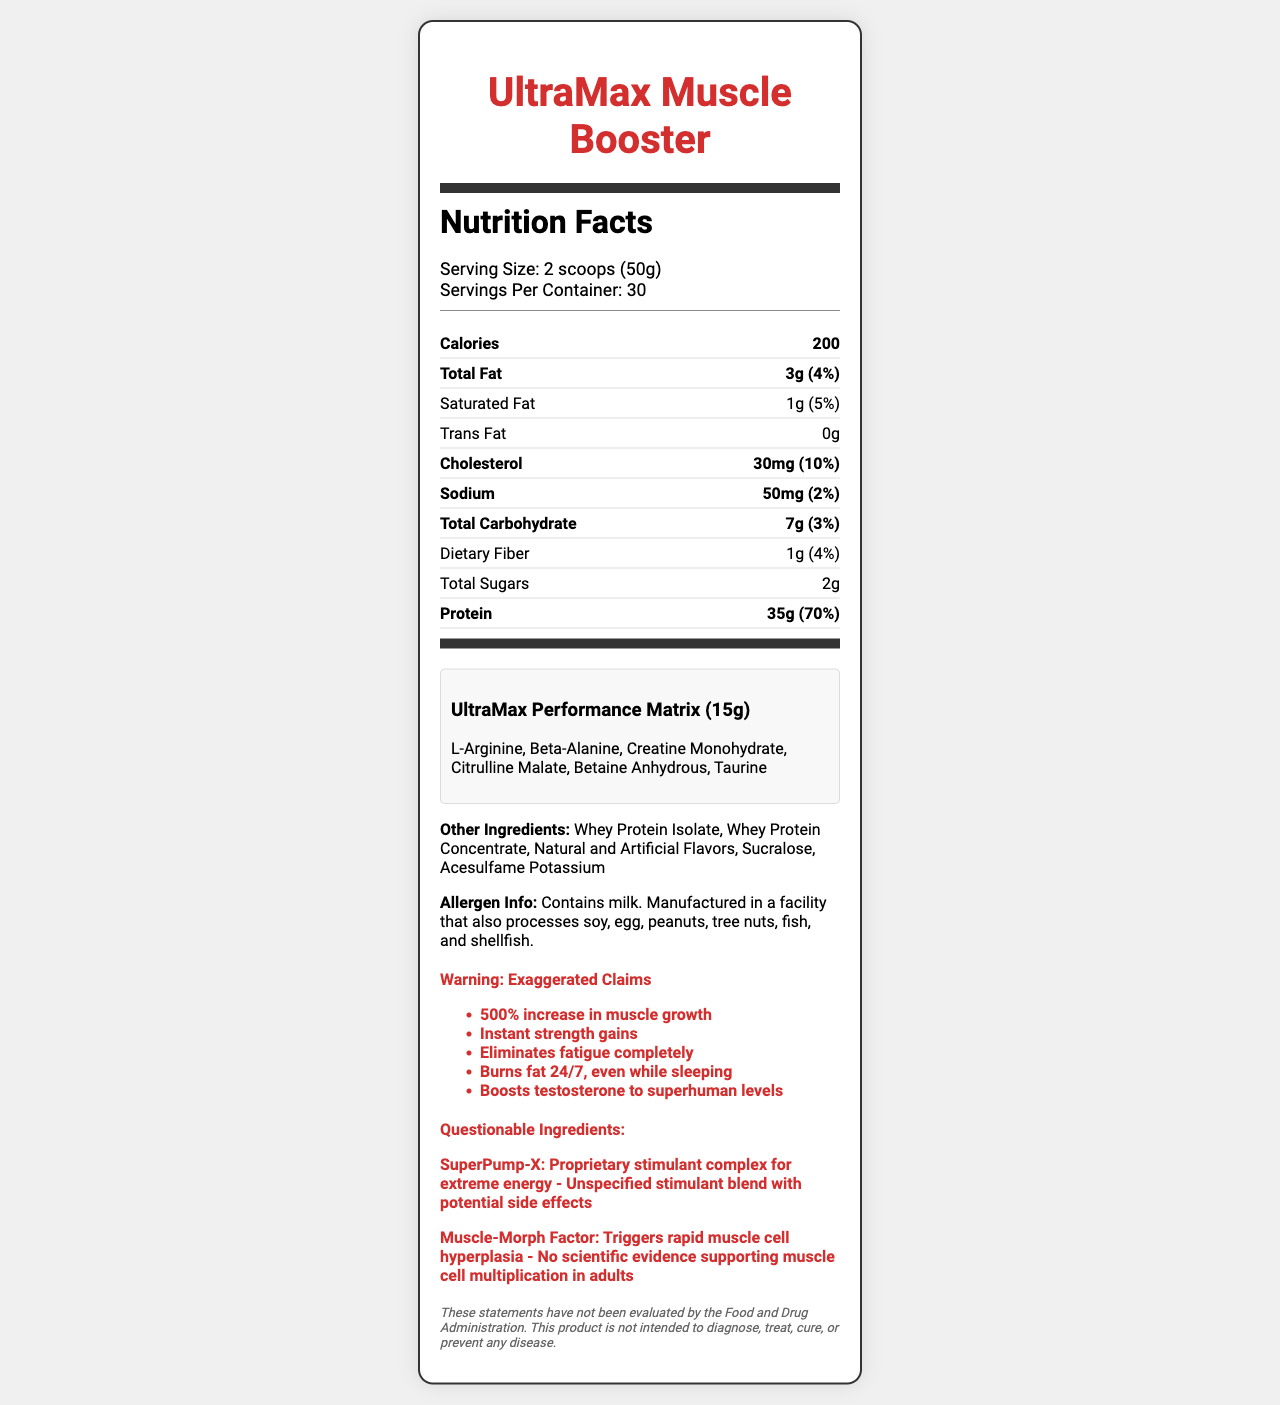what is the serving size of UltraMax Muscle Booster? The serving size is stated as "2 scoops (50g)" in the serving information section of the document.
Answer: 2 scoops (50g) how many calories are there per serving? The calories per serving is listed as 200.
Answer: 200 what is the total protein content per serving? The total protein content is listed as "35g" in the nutrient table.
Answer: 35g identify one questionable ingredient and its claimed benefit. This information is provided in the "Questionable Ingredients" section, where the ingredient SuperPump-X is claimed to be a proprietary stimulant complex for extreme energy.
Answer: SuperPump-X: Proprietary stimulant complex for extreme energy how many servings are there per container? The number of servings per container is given as 30 in the serving information section.
Answer: 30 what percentage of daily value does the cholesterol per serving contribute? A. 6% B. 10% C. 15% D. 20% The daily value percentage for cholesterol is listed as 10%.
Answer: B which of these is not listed as an ingredient for UltraMax Muscle Booster? I. Whey Protein Isolate II. Sucralose III. Aspartame IV. L-Arginine Aspartame is not listed under either the proprietary blend or other ingredients.
Answer: III is there any dietary fiber in this product? The nutrient table lists 1g of dietary fiber with a daily value of 4%.
Answer: Yes does this product boost testosterone to superhuman levels according to its claims? One of the exaggerated claims listed is "Boosts testosterone to superhuman levels."
Answer: Yes summarize the main idea of the document. The document primarily provides detailed nutritional information and ingredients of the UltraMax Muscle Booster, highlights exaggerated performance claims, and mentions questionable ingredients along with a disclaimer.
Answer: The document is a nutrition facts label for the sports nutrition supplement UltraMax Muscle Booster. It provides nutritional information, ingredient lists (including a proprietary blend and other ingredients), exaggerated performance claims, and highlights questionable ingredients. A disclaimer is included noting that the claims have not been evaluated by the FDA. how much vitamin D is present in each serving? According to the nutrient table, vitamin D content is 0 mcg with a daily value of 0%.
Answer: 0 mcg identify two flavors used in this product. The Other Ingredients section lists "Natural and Artificial Flavors".
Answer: Natural and Artificial Flavors is there any data supporting the "Muscle-Morph Factor" claim? The document notes that there is no scientific evidence supporting the muscle cell multiplication claim made by the "Muscle-Morph Factor."
Answer: No is the daily value percentage for total carbohydrates greater than 5%? The daily value for total carbohydrates is 3%, which is less than 5%.
Answer: No what is the proprietary blend name stated in the document? The document lists the proprietary blend under the name "UltraMax Performance Matrix".
Answer: UltraMax Performance Matrix list all allergens mentioned in this product. The allergen information section mentions these allergens.
Answer: Milk; manufactured in a facility that processes soy, egg, peanuts, tree nuts, fish, and shellfish what is the amount of calcium per serving? The calcium content per serving is listed as 200 mg.
Answer: 200 mg how much betaine anhydrous is in the proprietary blend? The document does not provide individual quantities for ingredients in the proprietary blend, only the total weight of the blend.
Answer: Not specified do the exaggerated claims say this product "Eliminates fatigue completely"? One of the exaggerated claims listed is "Eliminates fatigue completely."
Answer: Yes how many grams of total sugars are in the product? The nutrient table lists the total sugars content as 2g.
Answer: 2g who evaluated the claims made by this product? The disclaimer notes that the statements have not been evaluated by the FDA, but no other specific evaluator is mentioned.
Answer: Not enough information 